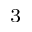<formula> <loc_0><loc_0><loc_500><loc_500>^ { 3 }</formula> 